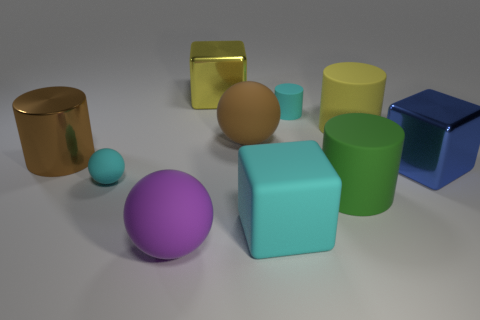Are there an equal number of big cylinders behind the big yellow matte thing and small matte objects that are right of the big purple sphere?
Offer a terse response. No. How many objects are either large brown objects in front of the large brown rubber ball or big objects that are in front of the blue cube?
Ensure brevity in your answer.  4. What is the material of the object that is both behind the cyan ball and left of the purple object?
Provide a succinct answer. Metal. How big is the cube that is in front of the large metallic block right of the big matte cylinder in front of the small sphere?
Your response must be concise. Large. Is the number of cyan matte objects greater than the number of large matte balls?
Provide a short and direct response. Yes. Do the cube that is on the left side of the brown sphere and the big cyan cube have the same material?
Provide a short and direct response. No. Is the number of gray matte cylinders less than the number of blue things?
Ensure brevity in your answer.  Yes. Is there a object that is to the right of the cyan thing in front of the tiny rubber object that is in front of the large blue metal thing?
Your response must be concise. Yes. There is a small cyan rubber thing in front of the blue thing; does it have the same shape as the big yellow metal thing?
Offer a very short reply. No. Is the number of things behind the yellow rubber cylinder greater than the number of tiny gray rubber blocks?
Offer a terse response. Yes. 